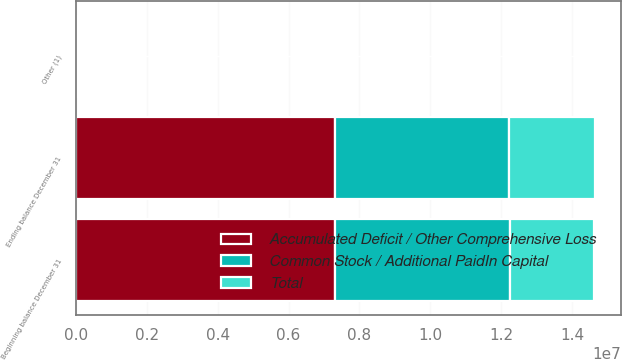<chart> <loc_0><loc_0><loc_500><loc_500><stacked_bar_chart><ecel><fcel>Beginning balance December 31<fcel>Other (1)<fcel>Ending balance December 31<nl><fcel>Accumulated Deficit / Other Comprehensive Loss<fcel>7.30972e+06<fcel>12047<fcel>7.32212e+06<nl><fcel>Total<fcel>2.38177e+06<fcel>2447<fcel>2.41765e+06<nl><fcel>Common Stock / Additional PaidIn Capital<fcel>4.92795e+06<fcel>14494<fcel>4.90447e+06<nl></chart> 